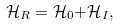<formula> <loc_0><loc_0><loc_500><loc_500>\mathcal { H } _ { R } = \mathcal { H } _ { 0 } \mathcal { + H } _ { I } ,</formula> 